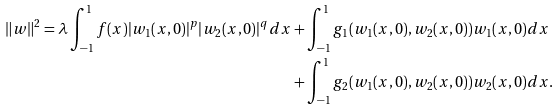Convert formula to latex. <formula><loc_0><loc_0><loc_500><loc_500>\| w \| ^ { 2 } = \lambda \int _ { - 1 } ^ { 1 } f ( x ) | w _ { 1 } ( x , 0 ) | ^ { p } | w _ { 2 } ( x , 0 ) | ^ { q } d x & + \int _ { - 1 } ^ { 1 } g _ { 1 } ( w _ { 1 } ( x , 0 ) , w _ { 2 } ( x , 0 ) ) w _ { 1 } ( x , 0 ) d x \\ & + \int _ { - 1 } ^ { 1 } g _ { 2 } ( w _ { 1 } ( x , 0 ) , w _ { 2 } ( x , 0 ) ) w _ { 2 } ( x , 0 ) d x .</formula> 